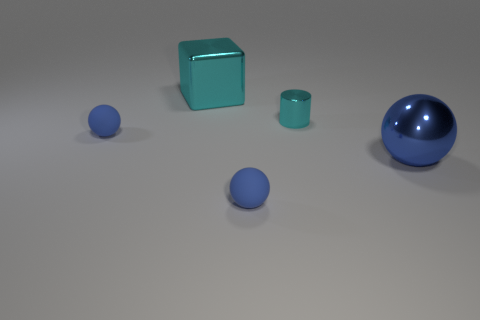There is a big blue metallic thing; does it have the same shape as the tiny object left of the large cube?
Provide a short and direct response. Yes. What is the color of the small thing that is left of the small metallic thing and behind the large blue metal thing?
Make the answer very short. Blue. Is there a tiny metal thing?
Your answer should be compact. Yes. Are there the same number of small rubber spheres right of the cylinder and large green shiny cubes?
Offer a very short reply. Yes. How many other objects are there of the same shape as the big blue object?
Your answer should be very brief. 2. What is the shape of the big blue metallic object?
Provide a short and direct response. Sphere. Are the big ball and the cyan cylinder made of the same material?
Offer a very short reply. Yes. Is the number of big cubes in front of the large cyan object the same as the number of cyan shiny objects that are on the right side of the metal sphere?
Your response must be concise. Yes. There is a large cyan metal block to the right of the matte sphere that is left of the large cyan metal block; are there any small blue things that are in front of it?
Your response must be concise. Yes. Do the cyan metal cylinder and the metal block have the same size?
Give a very brief answer. No. 